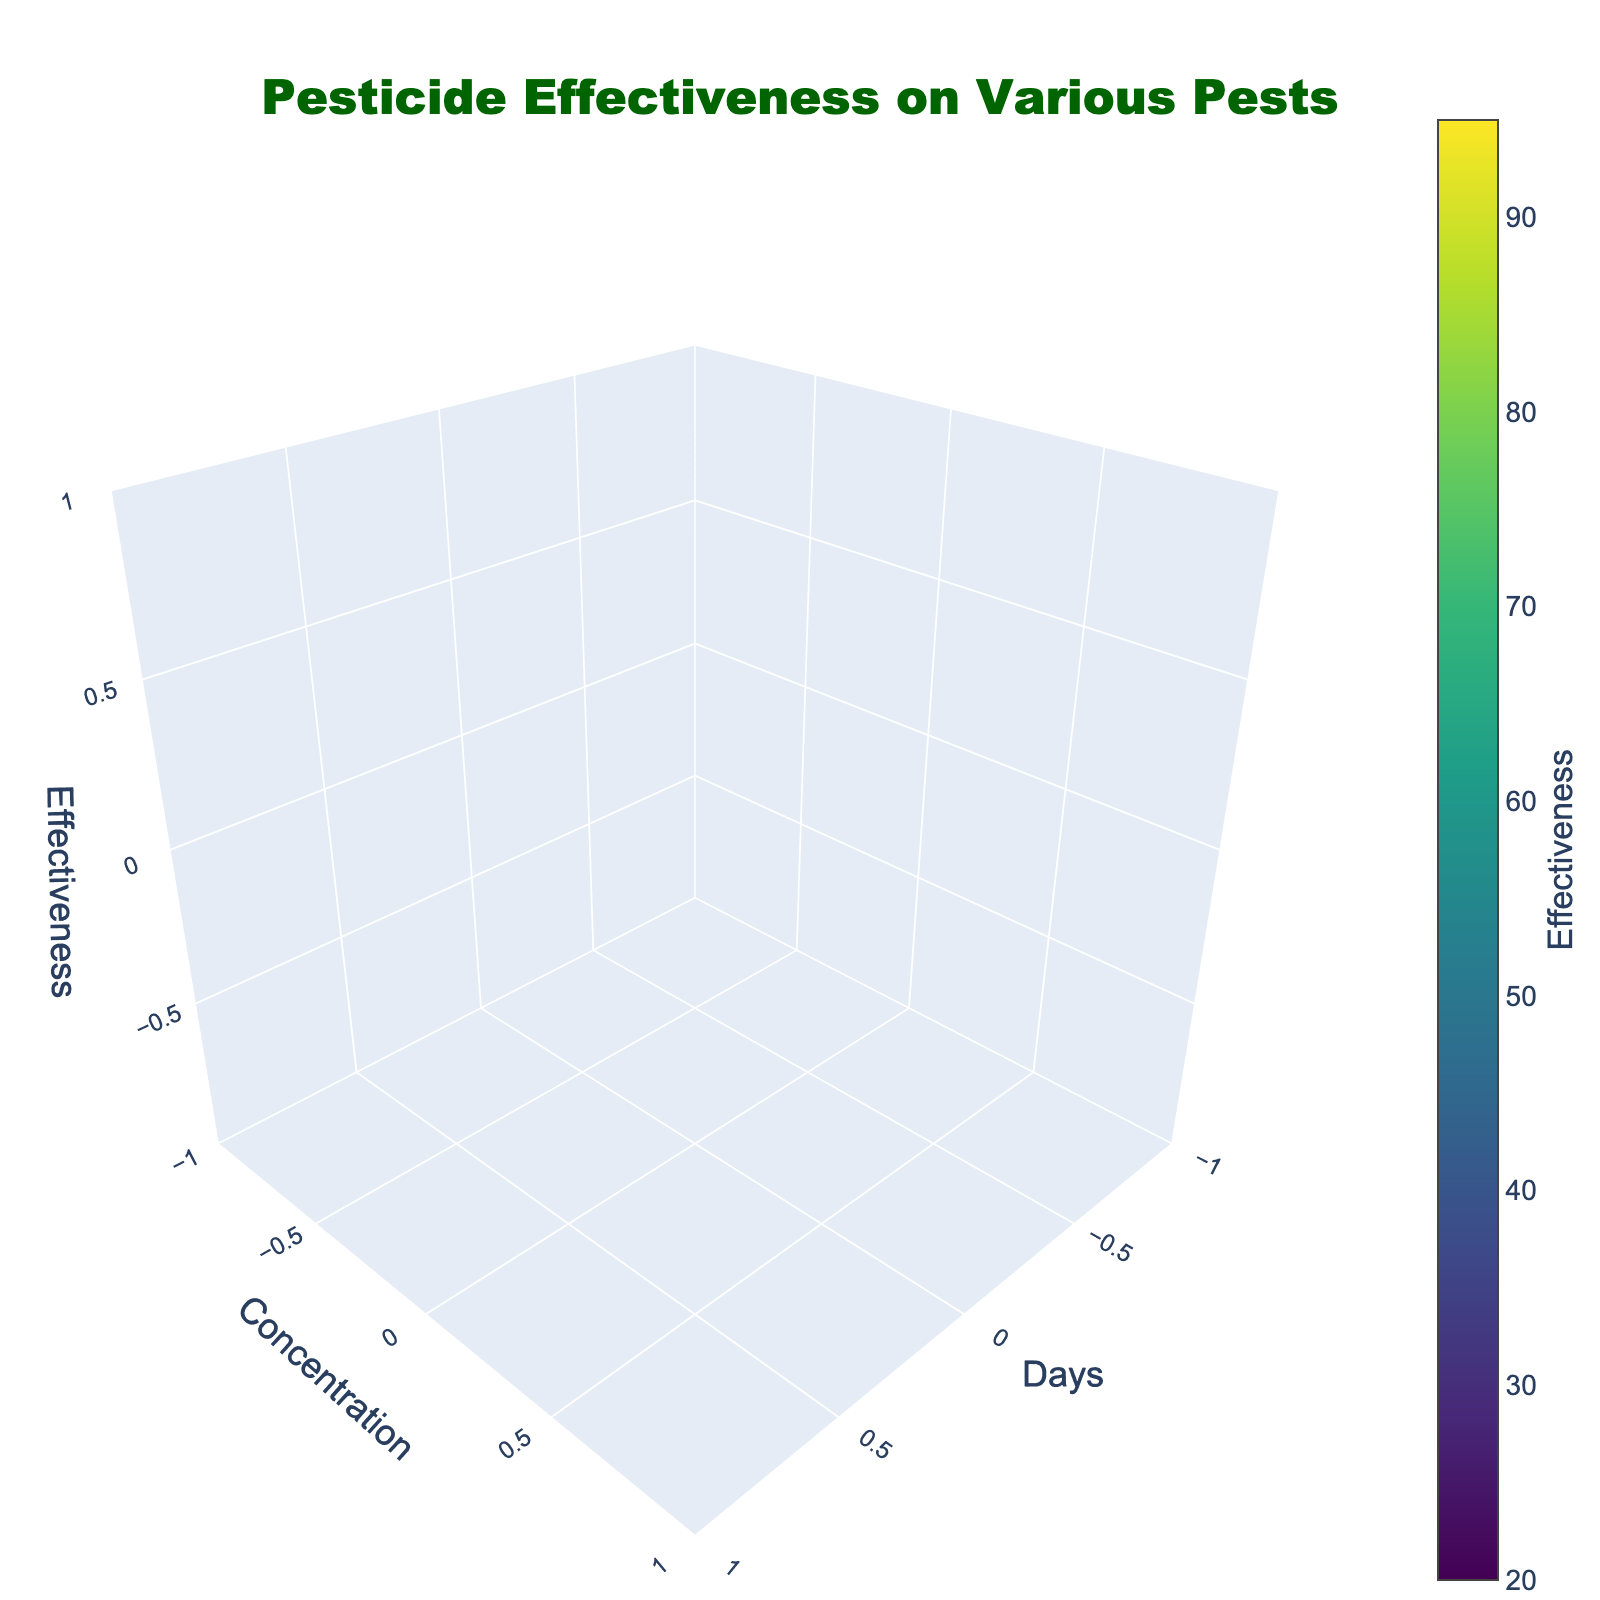What is the title of the figure? The title is displayed at the top of the figure, usually larger in size and more prominent than other texts. It is meant to describe what the figure is about.
Answer: Pesticide Effectiveness on Various Pests What are the labels of the x, y, and z axes? The labels of the axes are written next to each respective axis and identify what each axis represents, often showing units of measurement as well. From the figure, the x-axis shows the days, the y-axis shows the concentration, and the z-axis represents effectiveness.
Answer: Days, Concentration, Effectiveness What is the effectiveness value of pesticide at day 3 and concentration 1.0 for Aphid? In a 3D volume plot, you can navigate to the point corresponding to day 3 on the x-axis, concentration 1.0 on the y-axis, and look for the value on the z-axis related to Aphid. The effectiveness value at this point can be read directly from the plot.
Answer: 60 Which pest shows the highest effectiveness at day 7 with any concentration? You need to inspect the highest z-axis value (effectiveness) at day 7 for various concentration levels and determine which pest it corresponds to. Here, Cutworm at day 7 shows the highest effectiveness.
Answer: Cutworm What is the difference in effectiveness between concentration 0.5 and 1.5 for Corn Earworm on day 3? Identify the effectiveness values for Corn Earworm at concentration 0.5 and 1.5 on day 3, and then calculate the difference between these values.
Answer: 35 Which pest shows the least effectiveness at concentration 0.5 on day 1? Check the effectiveness values for all pests at concentration 0.5 on day 1. The pest with the lowest effectiveness value is the answer. Here, Corn Earworm shows the least effectiveness.
Answer: Corn Earworm How does the effectiveness change over time for Aphids at concentration 1.5? Observe the values for effectiveness at concentration 1.5 for Aphids across different days. Note the increase or decrease over days 1, 3, and 7. The values indicate the effectiveness increases over time.
Answer: Increases What is the average effectiveness for Cutworm at concentration 1.0 across all days? Identify the effectiveness values for Cutworm at concentration 1.0 on days 1, 3, and 7, sum these values, and then divide by the number of days (3 in this case).
Answer: 63.33 Which concentration level shows the highest overall effectiveness for Cutworm? Compare the effectiveness values at concentrations 0.5, 1.0, and 1.5 for Cutworm across all days. The concentration that consistently shows higher values on average is the answer.
Answer: 1.5 What does the color scale represent, and which colors indicate higher effectiveness? The color scale is a gradient representing effectiveness values, typically shown as a bar legend on the side of the plot. In the Viridis color scale, darker colors move from blue to green to yellow, indicating increasing effectiveness, with yellow indicating higher effectiveness.
Answer: Viridis scale; yellow 